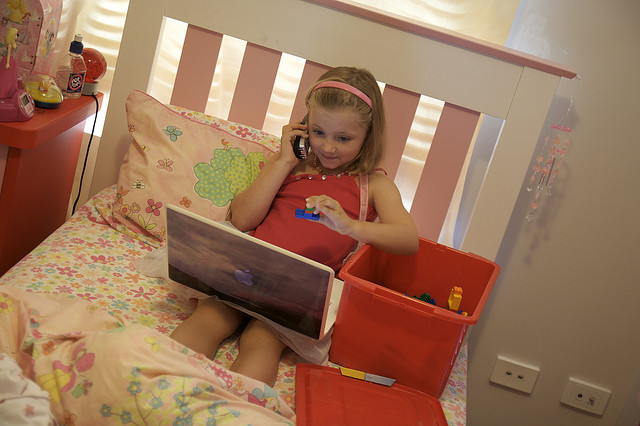<image>What cartoon character is on the pink pillow? I don't know. It can be a green turtle, flowers, dora, a fairy, or there may be none. What cartoon character is on the pink pillow? I don't know which cartoon character is on the pink pillow. It can be seen 'flowers', 'green turtle', 'flower', 'green', 'dora', 'none', 'flowers', 'fairy', or 'turtle'. 